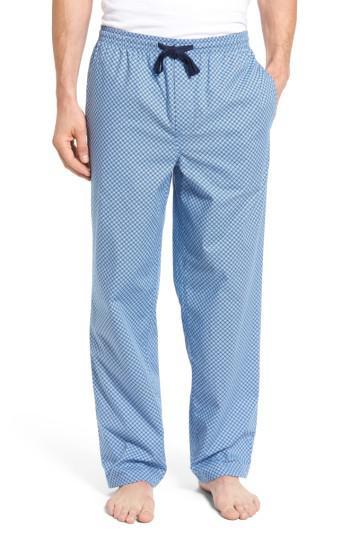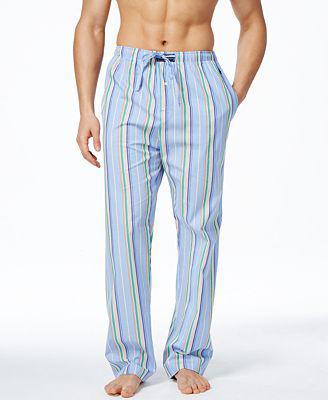The first image is the image on the left, the second image is the image on the right. Given the left and right images, does the statement "The image on the left has a man's leg bending to the right with his heel up." hold true? Answer yes or no. No. 